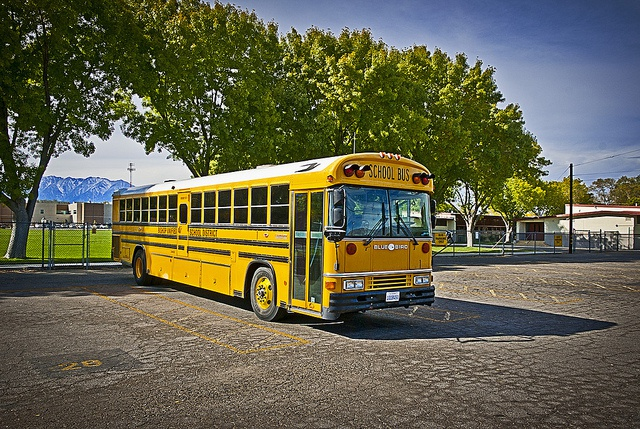Describe the objects in this image and their specific colors. I can see bus in black, gold, orange, and olive tones in this image. 